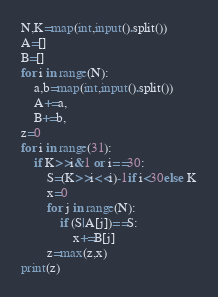<code> <loc_0><loc_0><loc_500><loc_500><_Python_>N,K=map(int,input().split())
A=[]
B=[]
for i in range(N):
	a,b=map(int,input().split())
	A+=a,
	B+=b,
z=0
for i in range(31):
	if K>>i&1 or i==30:
		S=(K>>i<<i)-1if i<30else K
		x=0
		for j in range(N):
			if (S|A[j])==S:
				x+=B[j]
		z=max(z,x)
print(z)</code> 